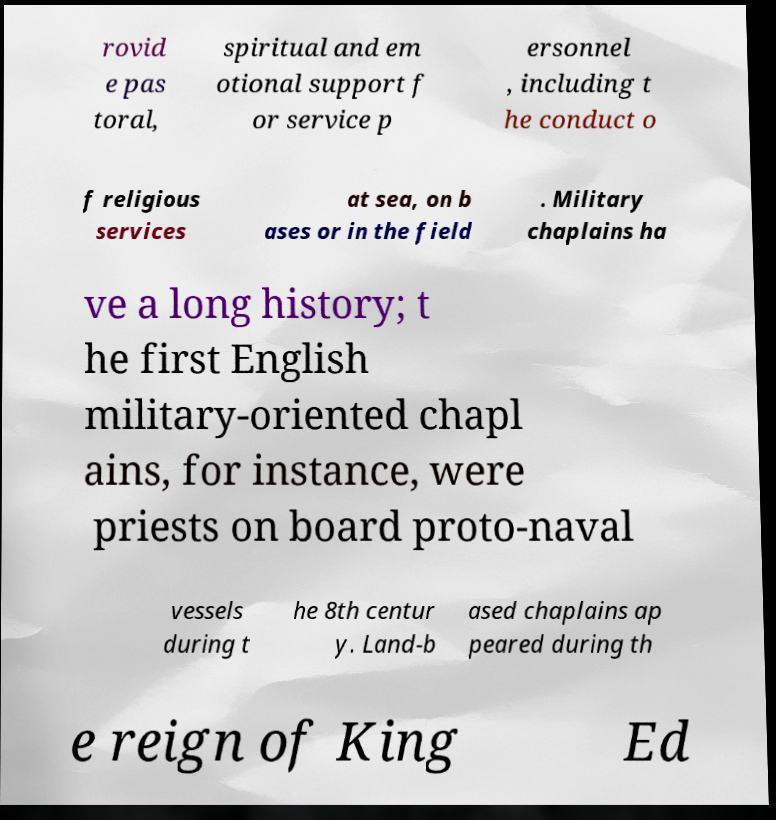Please read and relay the text visible in this image. What does it say? rovid e pas toral, spiritual and em otional support f or service p ersonnel , including t he conduct o f religious services at sea, on b ases or in the field . Military chaplains ha ve a long history; t he first English military-oriented chapl ains, for instance, were priests on board proto-naval vessels during t he 8th centur y. Land-b ased chaplains ap peared during th e reign of King Ed 